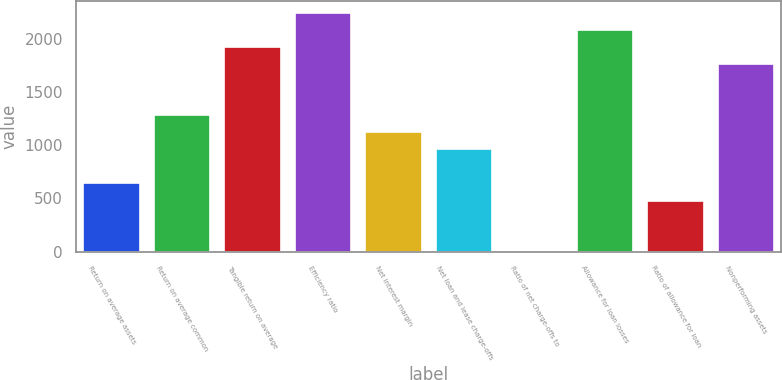<chart> <loc_0><loc_0><loc_500><loc_500><bar_chart><fcel>Return on average assets<fcel>Return on average common<fcel>Tangible return on average<fcel>Efficiency ratio<fcel>Net interest margin<fcel>Net loan and lease charge-offs<fcel>Ratio of net charge-offs to<fcel>Allowance for loan losses<fcel>Ratio of allowance for loan<fcel>Nonperforming assets<nl><fcel>639.63<fcel>1279.23<fcel>1918.83<fcel>2238.63<fcel>1119.33<fcel>959.43<fcel>0.03<fcel>2078.73<fcel>479.73<fcel>1758.93<nl></chart> 